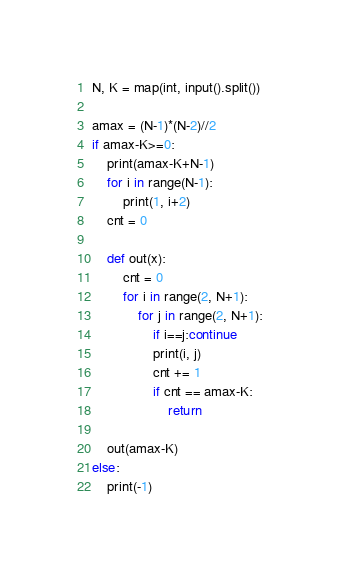<code> <loc_0><loc_0><loc_500><loc_500><_Python_>N, K = map(int, input().split())

amax = (N-1)*(N-2)//2
if amax-K>=0:
    print(amax-K+N-1)
    for i in range(N-1):
        print(1, i+2)
    cnt = 0

    def out(x):
        cnt = 0
        for i in range(2, N+1):
            for j in range(2, N+1):
                if i==j:continue
                print(i, j)
                cnt += 1
                if cnt == amax-K:
                    return

    out(amax-K)
else:
    print(-1)</code> 